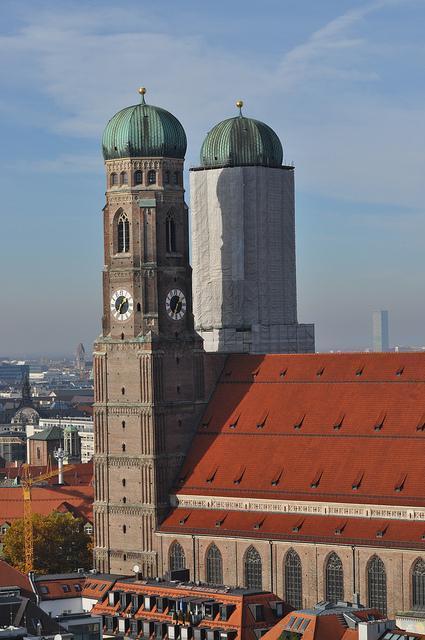How many people are inside of the truck?
Give a very brief answer. 0. 